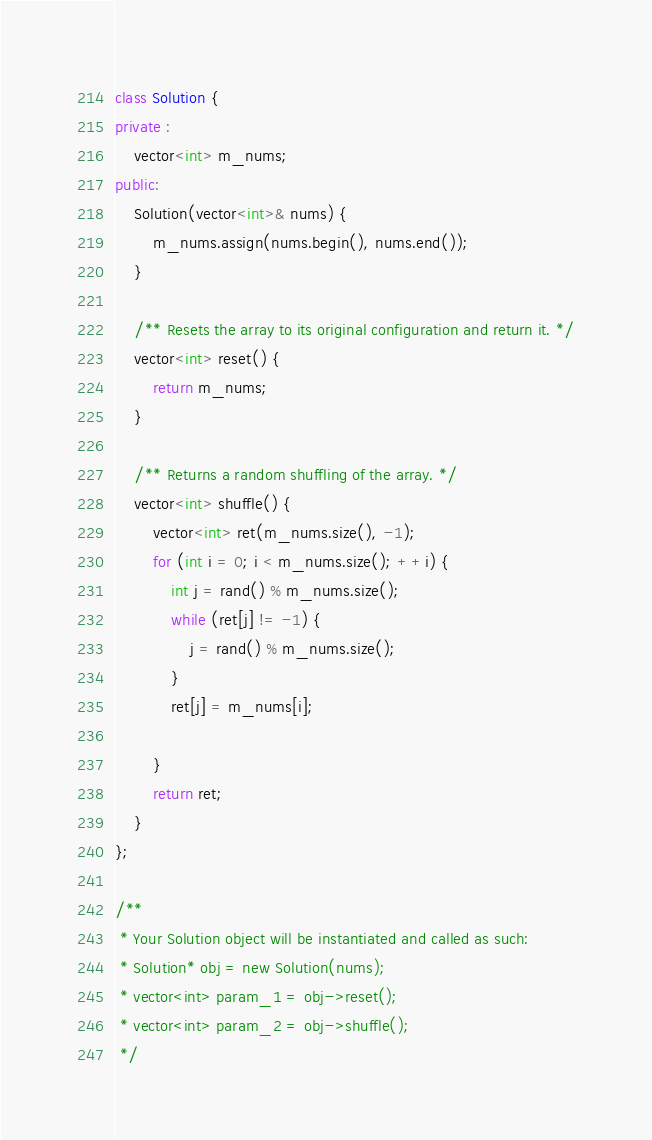Convert code to text. <code><loc_0><loc_0><loc_500><loc_500><_C++_>class Solution {
private :
    vector<int> m_nums;
public:
    Solution(vector<int>& nums) {
        m_nums.assign(nums.begin(), nums.end());
    }
    
    /** Resets the array to its original configuration and return it. */
    vector<int> reset() {
        return m_nums;
    }
    
    /** Returns a random shuffling of the array. */
    vector<int> shuffle() {
        vector<int> ret(m_nums.size(), -1);
        for (int i = 0; i < m_nums.size(); ++i) {
            int j = rand() % m_nums.size();
            while (ret[j] != -1) {
                j = rand() % m_nums.size();
            }
            ret[j] = m_nums[i];

        }
        return ret;
    }
};

/**
 * Your Solution object will be instantiated and called as such:
 * Solution* obj = new Solution(nums);
 * vector<int> param_1 = obj->reset();
 * vector<int> param_2 = obj->shuffle();
 */
</code> 